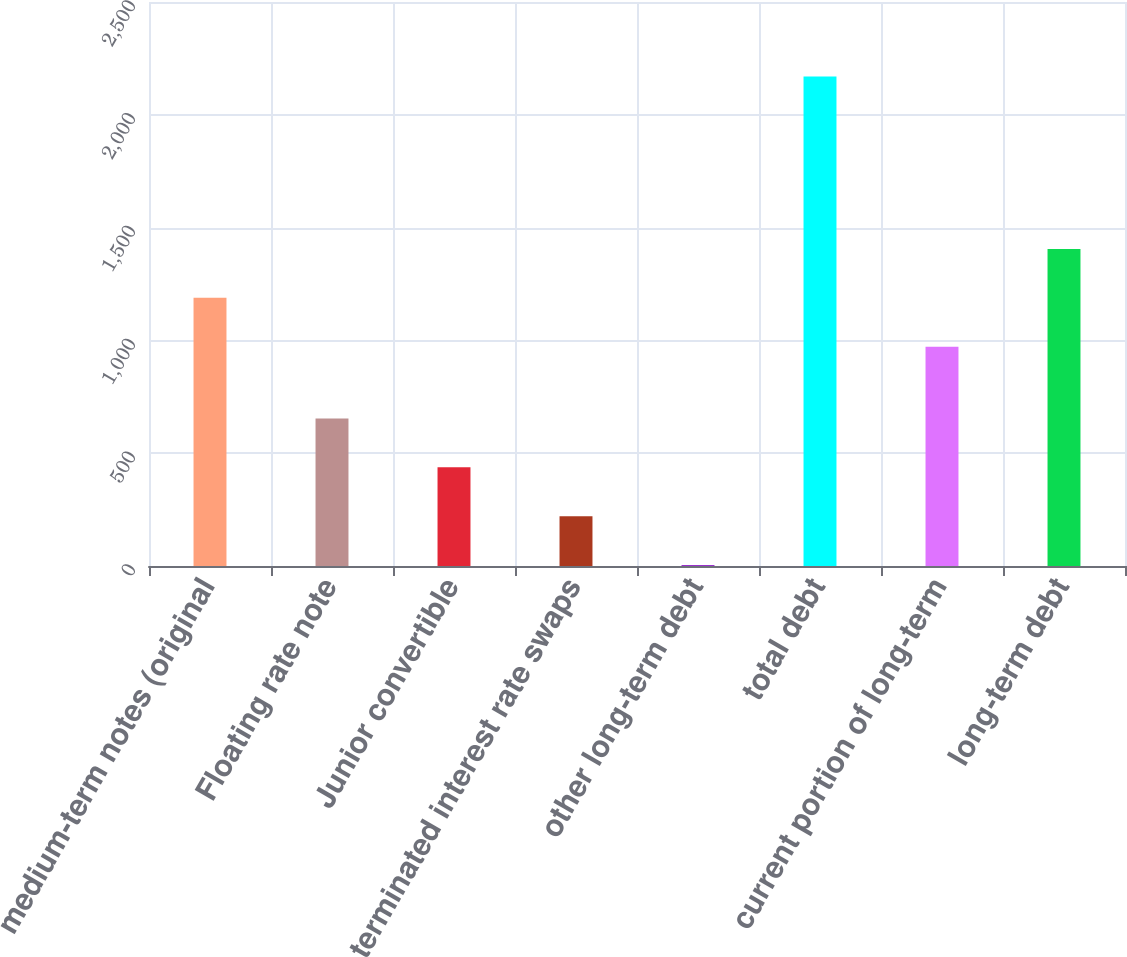Convert chart to OTSL. <chart><loc_0><loc_0><loc_500><loc_500><bar_chart><fcel>medium-term notes (original<fcel>Floating rate note<fcel>Junior convertible<fcel>terminated interest rate swaps<fcel>other long-term debt<fcel>total debt<fcel>current portion of long-term<fcel>long-term debt<nl><fcel>1188.72<fcel>653.96<fcel>437.44<fcel>220.92<fcel>4.4<fcel>2169.6<fcel>972.2<fcel>1405.24<nl></chart> 